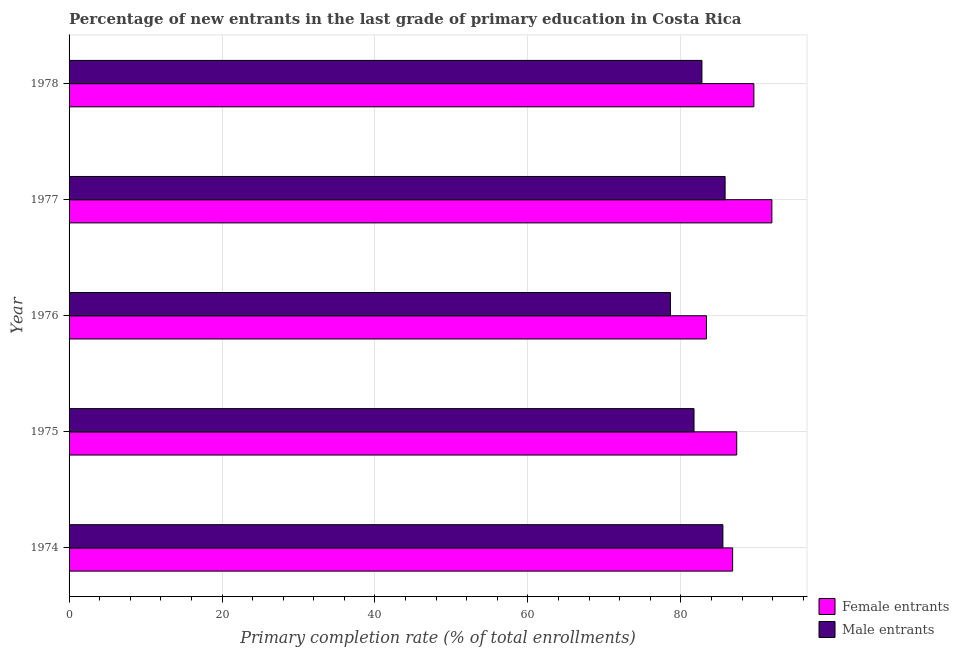How many different coloured bars are there?
Make the answer very short. 2. How many groups of bars are there?
Offer a very short reply. 5. Are the number of bars on each tick of the Y-axis equal?
Keep it short and to the point. Yes. What is the label of the 5th group of bars from the top?
Ensure brevity in your answer.  1974. What is the primary completion rate of male entrants in 1975?
Your response must be concise. 81.71. Across all years, what is the maximum primary completion rate of male entrants?
Offer a terse response. 85.78. Across all years, what is the minimum primary completion rate of female entrants?
Ensure brevity in your answer.  83.34. In which year was the primary completion rate of female entrants maximum?
Provide a succinct answer. 1977. In which year was the primary completion rate of male entrants minimum?
Give a very brief answer. 1976. What is the total primary completion rate of male entrants in the graph?
Give a very brief answer. 414.37. What is the difference between the primary completion rate of female entrants in 1975 and that in 1977?
Your response must be concise. -4.59. What is the difference between the primary completion rate of female entrants in 1976 and the primary completion rate of male entrants in 1977?
Offer a terse response. -2.44. What is the average primary completion rate of female entrants per year?
Your answer should be compact. 87.77. In the year 1978, what is the difference between the primary completion rate of female entrants and primary completion rate of male entrants?
Your response must be concise. 6.79. What is the ratio of the primary completion rate of female entrants in 1974 to that in 1978?
Your answer should be compact. 0.97. Is the primary completion rate of female entrants in 1976 less than that in 1977?
Your response must be concise. Yes. Is the difference between the primary completion rate of male entrants in 1975 and 1978 greater than the difference between the primary completion rate of female entrants in 1975 and 1978?
Ensure brevity in your answer.  Yes. What is the difference between the highest and the second highest primary completion rate of female entrants?
Provide a short and direct response. 2.35. What is the difference between the highest and the lowest primary completion rate of female entrants?
Provide a short and direct response. 8.55. What does the 2nd bar from the top in 1975 represents?
Give a very brief answer. Female entrants. What does the 2nd bar from the bottom in 1974 represents?
Keep it short and to the point. Male entrants. Are all the bars in the graph horizontal?
Provide a succinct answer. Yes. How many years are there in the graph?
Ensure brevity in your answer.  5. Does the graph contain grids?
Your answer should be compact. Yes. Where does the legend appear in the graph?
Give a very brief answer. Bottom right. How are the legend labels stacked?
Keep it short and to the point. Vertical. What is the title of the graph?
Provide a succinct answer. Percentage of new entrants in the last grade of primary education in Costa Rica. Does "Unregistered firms" appear as one of the legend labels in the graph?
Your answer should be compact. No. What is the label or title of the X-axis?
Provide a succinct answer. Primary completion rate (% of total enrollments). What is the Primary completion rate (% of total enrollments) in Female entrants in 1974?
Provide a succinct answer. 86.76. What is the Primary completion rate (% of total enrollments) of Male entrants in 1974?
Give a very brief answer. 85.49. What is the Primary completion rate (% of total enrollments) in Female entrants in 1975?
Give a very brief answer. 87.3. What is the Primary completion rate (% of total enrollments) of Male entrants in 1975?
Offer a terse response. 81.71. What is the Primary completion rate (% of total enrollments) in Female entrants in 1976?
Your answer should be compact. 83.34. What is the Primary completion rate (% of total enrollments) of Male entrants in 1976?
Ensure brevity in your answer.  78.63. What is the Primary completion rate (% of total enrollments) of Female entrants in 1977?
Provide a succinct answer. 91.89. What is the Primary completion rate (% of total enrollments) of Male entrants in 1977?
Provide a succinct answer. 85.78. What is the Primary completion rate (% of total enrollments) of Female entrants in 1978?
Your response must be concise. 89.54. What is the Primary completion rate (% of total enrollments) in Male entrants in 1978?
Your answer should be very brief. 82.75. Across all years, what is the maximum Primary completion rate (% of total enrollments) in Female entrants?
Your response must be concise. 91.89. Across all years, what is the maximum Primary completion rate (% of total enrollments) of Male entrants?
Ensure brevity in your answer.  85.78. Across all years, what is the minimum Primary completion rate (% of total enrollments) of Female entrants?
Provide a short and direct response. 83.34. Across all years, what is the minimum Primary completion rate (% of total enrollments) of Male entrants?
Make the answer very short. 78.63. What is the total Primary completion rate (% of total enrollments) of Female entrants in the graph?
Your response must be concise. 438.84. What is the total Primary completion rate (% of total enrollments) in Male entrants in the graph?
Provide a short and direct response. 414.37. What is the difference between the Primary completion rate (% of total enrollments) in Female entrants in 1974 and that in 1975?
Provide a short and direct response. -0.54. What is the difference between the Primary completion rate (% of total enrollments) in Male entrants in 1974 and that in 1975?
Give a very brief answer. 3.78. What is the difference between the Primary completion rate (% of total enrollments) of Female entrants in 1974 and that in 1976?
Provide a succinct answer. 3.42. What is the difference between the Primary completion rate (% of total enrollments) in Male entrants in 1974 and that in 1976?
Offer a very short reply. 6.86. What is the difference between the Primary completion rate (% of total enrollments) in Female entrants in 1974 and that in 1977?
Your answer should be very brief. -5.13. What is the difference between the Primary completion rate (% of total enrollments) in Male entrants in 1974 and that in 1977?
Provide a short and direct response. -0.29. What is the difference between the Primary completion rate (% of total enrollments) in Female entrants in 1974 and that in 1978?
Your answer should be compact. -2.78. What is the difference between the Primary completion rate (% of total enrollments) in Male entrants in 1974 and that in 1978?
Ensure brevity in your answer.  2.74. What is the difference between the Primary completion rate (% of total enrollments) in Female entrants in 1975 and that in 1976?
Your answer should be very brief. 3.96. What is the difference between the Primary completion rate (% of total enrollments) in Male entrants in 1975 and that in 1976?
Your answer should be compact. 3.08. What is the difference between the Primary completion rate (% of total enrollments) in Female entrants in 1975 and that in 1977?
Keep it short and to the point. -4.59. What is the difference between the Primary completion rate (% of total enrollments) of Male entrants in 1975 and that in 1977?
Ensure brevity in your answer.  -4.07. What is the difference between the Primary completion rate (% of total enrollments) in Female entrants in 1975 and that in 1978?
Your answer should be very brief. -2.24. What is the difference between the Primary completion rate (% of total enrollments) of Male entrants in 1975 and that in 1978?
Your answer should be very brief. -1.04. What is the difference between the Primary completion rate (% of total enrollments) of Female entrants in 1976 and that in 1977?
Provide a short and direct response. -8.55. What is the difference between the Primary completion rate (% of total enrollments) in Male entrants in 1976 and that in 1977?
Your answer should be very brief. -7.15. What is the difference between the Primary completion rate (% of total enrollments) in Female entrants in 1976 and that in 1978?
Offer a terse response. -6.2. What is the difference between the Primary completion rate (% of total enrollments) of Male entrants in 1976 and that in 1978?
Offer a terse response. -4.12. What is the difference between the Primary completion rate (% of total enrollments) of Female entrants in 1977 and that in 1978?
Give a very brief answer. 2.35. What is the difference between the Primary completion rate (% of total enrollments) of Male entrants in 1977 and that in 1978?
Give a very brief answer. 3.03. What is the difference between the Primary completion rate (% of total enrollments) of Female entrants in 1974 and the Primary completion rate (% of total enrollments) of Male entrants in 1975?
Offer a very short reply. 5.05. What is the difference between the Primary completion rate (% of total enrollments) of Female entrants in 1974 and the Primary completion rate (% of total enrollments) of Male entrants in 1976?
Give a very brief answer. 8.13. What is the difference between the Primary completion rate (% of total enrollments) of Female entrants in 1974 and the Primary completion rate (% of total enrollments) of Male entrants in 1977?
Your answer should be compact. 0.98. What is the difference between the Primary completion rate (% of total enrollments) in Female entrants in 1974 and the Primary completion rate (% of total enrollments) in Male entrants in 1978?
Provide a succinct answer. 4.01. What is the difference between the Primary completion rate (% of total enrollments) in Female entrants in 1975 and the Primary completion rate (% of total enrollments) in Male entrants in 1976?
Provide a short and direct response. 8.67. What is the difference between the Primary completion rate (% of total enrollments) of Female entrants in 1975 and the Primary completion rate (% of total enrollments) of Male entrants in 1977?
Your answer should be compact. 1.52. What is the difference between the Primary completion rate (% of total enrollments) of Female entrants in 1975 and the Primary completion rate (% of total enrollments) of Male entrants in 1978?
Your response must be concise. 4.55. What is the difference between the Primary completion rate (% of total enrollments) in Female entrants in 1976 and the Primary completion rate (% of total enrollments) in Male entrants in 1977?
Offer a terse response. -2.44. What is the difference between the Primary completion rate (% of total enrollments) in Female entrants in 1976 and the Primary completion rate (% of total enrollments) in Male entrants in 1978?
Your response must be concise. 0.59. What is the difference between the Primary completion rate (% of total enrollments) of Female entrants in 1977 and the Primary completion rate (% of total enrollments) of Male entrants in 1978?
Offer a terse response. 9.14. What is the average Primary completion rate (% of total enrollments) of Female entrants per year?
Provide a short and direct response. 87.77. What is the average Primary completion rate (% of total enrollments) in Male entrants per year?
Make the answer very short. 82.87. In the year 1974, what is the difference between the Primary completion rate (% of total enrollments) of Female entrants and Primary completion rate (% of total enrollments) of Male entrants?
Keep it short and to the point. 1.27. In the year 1975, what is the difference between the Primary completion rate (% of total enrollments) in Female entrants and Primary completion rate (% of total enrollments) in Male entrants?
Ensure brevity in your answer.  5.59. In the year 1976, what is the difference between the Primary completion rate (% of total enrollments) in Female entrants and Primary completion rate (% of total enrollments) in Male entrants?
Offer a terse response. 4.71. In the year 1977, what is the difference between the Primary completion rate (% of total enrollments) of Female entrants and Primary completion rate (% of total enrollments) of Male entrants?
Provide a short and direct response. 6.11. In the year 1978, what is the difference between the Primary completion rate (% of total enrollments) of Female entrants and Primary completion rate (% of total enrollments) of Male entrants?
Provide a succinct answer. 6.79. What is the ratio of the Primary completion rate (% of total enrollments) of Male entrants in 1974 to that in 1975?
Your answer should be very brief. 1.05. What is the ratio of the Primary completion rate (% of total enrollments) of Female entrants in 1974 to that in 1976?
Offer a very short reply. 1.04. What is the ratio of the Primary completion rate (% of total enrollments) in Male entrants in 1974 to that in 1976?
Provide a succinct answer. 1.09. What is the ratio of the Primary completion rate (% of total enrollments) of Female entrants in 1974 to that in 1977?
Your answer should be very brief. 0.94. What is the ratio of the Primary completion rate (% of total enrollments) of Female entrants in 1974 to that in 1978?
Keep it short and to the point. 0.97. What is the ratio of the Primary completion rate (% of total enrollments) in Male entrants in 1974 to that in 1978?
Your response must be concise. 1.03. What is the ratio of the Primary completion rate (% of total enrollments) in Female entrants in 1975 to that in 1976?
Your answer should be compact. 1.05. What is the ratio of the Primary completion rate (% of total enrollments) of Male entrants in 1975 to that in 1976?
Provide a short and direct response. 1.04. What is the ratio of the Primary completion rate (% of total enrollments) of Male entrants in 1975 to that in 1977?
Your answer should be very brief. 0.95. What is the ratio of the Primary completion rate (% of total enrollments) of Male entrants in 1975 to that in 1978?
Your answer should be compact. 0.99. What is the ratio of the Primary completion rate (% of total enrollments) of Female entrants in 1976 to that in 1977?
Ensure brevity in your answer.  0.91. What is the ratio of the Primary completion rate (% of total enrollments) in Female entrants in 1976 to that in 1978?
Provide a succinct answer. 0.93. What is the ratio of the Primary completion rate (% of total enrollments) of Male entrants in 1976 to that in 1978?
Provide a succinct answer. 0.95. What is the ratio of the Primary completion rate (% of total enrollments) in Female entrants in 1977 to that in 1978?
Your answer should be very brief. 1.03. What is the ratio of the Primary completion rate (% of total enrollments) in Male entrants in 1977 to that in 1978?
Your response must be concise. 1.04. What is the difference between the highest and the second highest Primary completion rate (% of total enrollments) in Female entrants?
Your answer should be compact. 2.35. What is the difference between the highest and the second highest Primary completion rate (% of total enrollments) of Male entrants?
Offer a very short reply. 0.29. What is the difference between the highest and the lowest Primary completion rate (% of total enrollments) of Female entrants?
Give a very brief answer. 8.55. What is the difference between the highest and the lowest Primary completion rate (% of total enrollments) in Male entrants?
Offer a terse response. 7.15. 